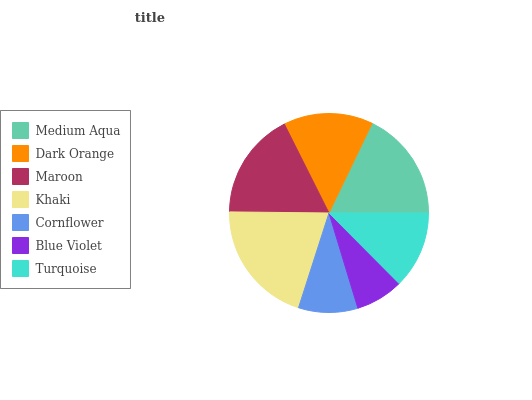Is Blue Violet the minimum?
Answer yes or no. Yes. Is Khaki the maximum?
Answer yes or no. Yes. Is Dark Orange the minimum?
Answer yes or no. No. Is Dark Orange the maximum?
Answer yes or no. No. Is Medium Aqua greater than Dark Orange?
Answer yes or no. Yes. Is Dark Orange less than Medium Aqua?
Answer yes or no. Yes. Is Dark Orange greater than Medium Aqua?
Answer yes or no. No. Is Medium Aqua less than Dark Orange?
Answer yes or no. No. Is Dark Orange the high median?
Answer yes or no. Yes. Is Dark Orange the low median?
Answer yes or no. Yes. Is Khaki the high median?
Answer yes or no. No. Is Blue Violet the low median?
Answer yes or no. No. 